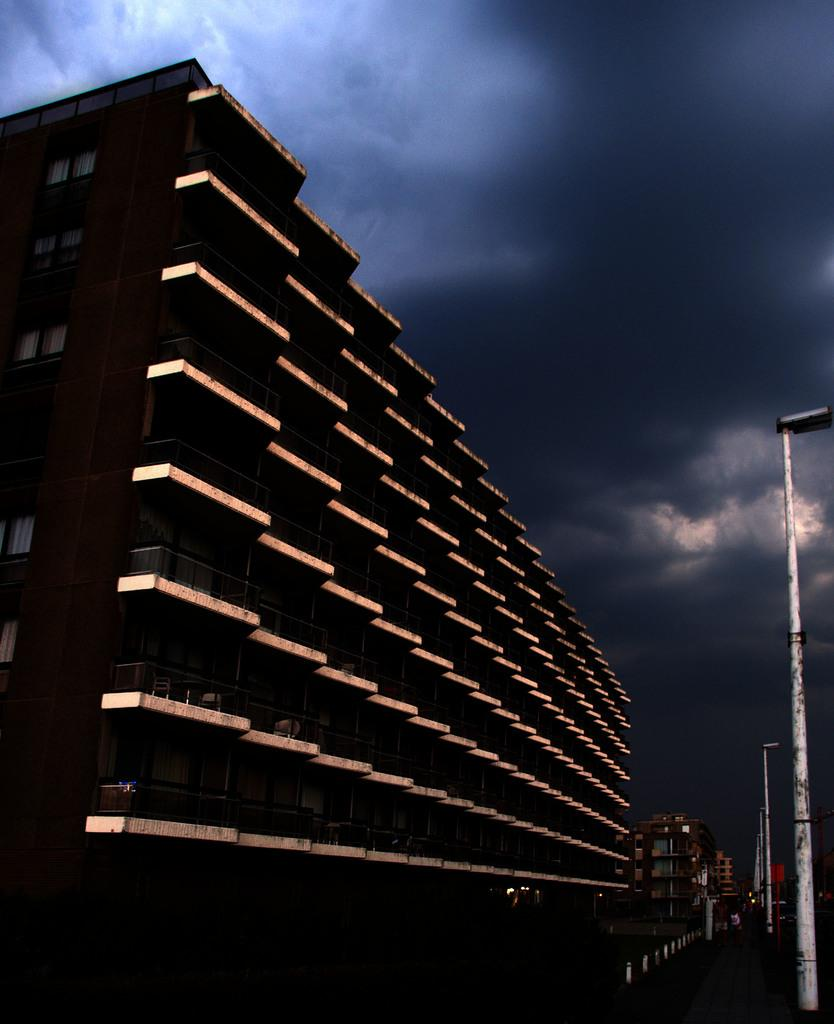What type of structures can be seen in the image? There are light poles and buildings in the image. What else can be seen in the image besides structures? There are poles and a board in the image. What is visible in the sky in the background of the image? There are clouds in the sky in the background of the image. What type of legs are visible on the board in the image? There are no legs visible on the board in the image. The board is a flat, two-dimensional object. 